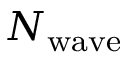Convert formula to latex. <formula><loc_0><loc_0><loc_500><loc_500>N _ { w a v e }</formula> 